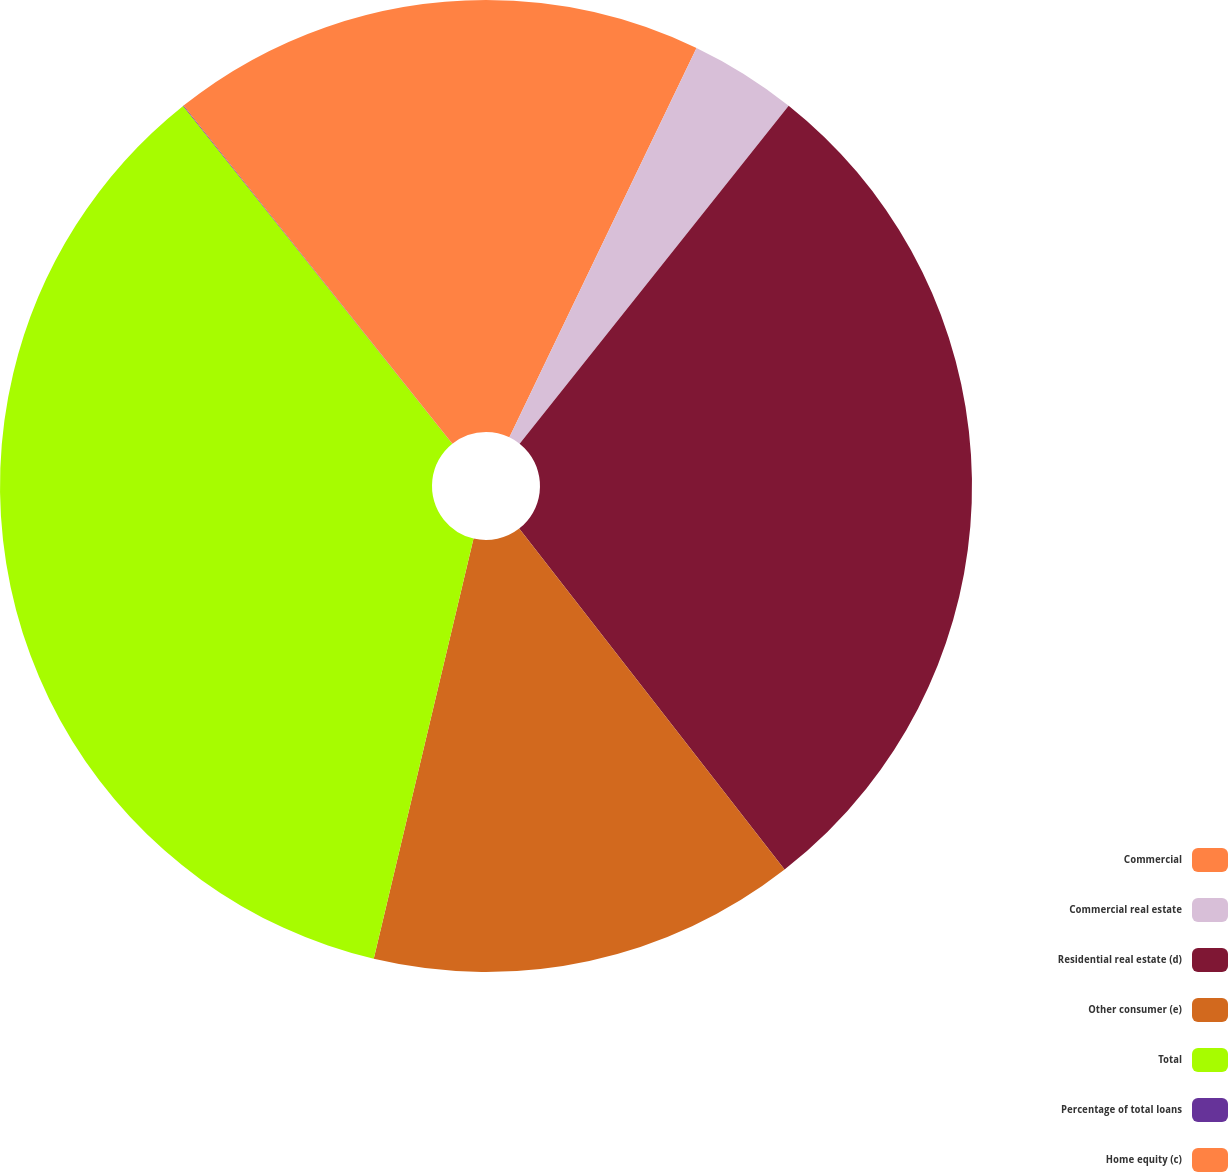<chart> <loc_0><loc_0><loc_500><loc_500><pie_chart><fcel>Commercial<fcel>Commercial real estate<fcel>Residential real estate (d)<fcel>Other consumer (e)<fcel>Total<fcel>Percentage of total loans<fcel>Home equity (c)<nl><fcel>7.13%<fcel>3.57%<fcel>28.77%<fcel>14.24%<fcel>35.58%<fcel>0.02%<fcel>10.69%<nl></chart> 